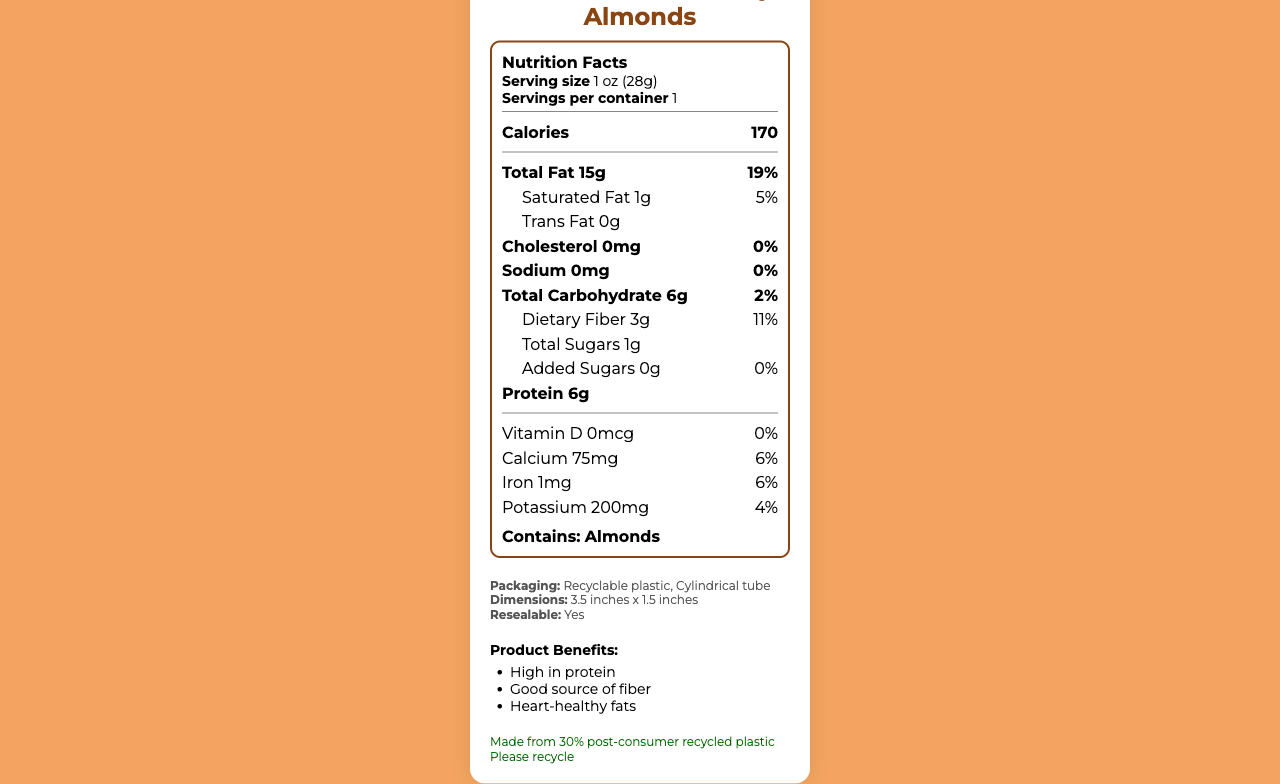what is the serving size? The serving size is stated right after the label "Serving size" within the "serving-info" section.
Answer: 1 oz (28g) how much protein does one serving contain? The document lists "Protein 6g" under the nutrition facts section.
Answer: 6g how many calories are in one serving? The document lists "Calories 170" in bold under the Nutrition Facts heading.
Answer: 170 is there any cholesterol in SmartSnack Crunchy Almonds? The document specifies "Cholesterol 0mg" with a daily value of "0%", indicating no cholesterol.
Answer: No what allergens does the product contain? The allergen information is clearly stated at the bottom of the nutrition facts, noting "Contains: Almonds".
Answer: Almonds which nutrient has a daily value of 19%? The document lists "Total Fat 15g" next to "19%" indicating it's 19% of the daily value.
Answer: Total Fat what is the shape of the packaging? A. Box B. Cylindrical tube C. Bag The packaging features section specifies the shape as "Cylindrical tube".
Answer: B what material is used for the packaging? A. Cardboard B. Glass C. Recyclable plastic The packaging features section states that the material used is "Recyclable plastic".
Answer: C does the packaging have resealable features? The packaging features section indicates that the package is "Resealable: Yes".
Answer: Yes how is the product environmentally friendly? The sustainability section mentions that the packaging is made from 30% post-consumer recycled plastic and encourages recycling.
Answer: The packaging is made from 30% post-consumer recycled plastic which vitamin mentioned has a daily value of 0%? The document lists "Vitamin D 0mcg" with a daily value of "0%", showing it does not contribute to daily Vitamin D intake.
Answer: Vitamin D name one benefit of the product. The product benefits section lists multiple benefits, including "High in protein" as one of them.
Answer: High in protein what is the tagline for the portion control messaging? The portion control messaging section includes the tagline "Perfect portion, powerful nutrition".
Answer: Perfect portion, powerful nutrition does the product contain any added sugars? The document states "Added Sugars 0g" with a daily value of "0%".
Answer: No summerize the entire document. This is a comprehensive description of the entire document and the information it provides.
Answer: The Nutrition Facts Label for SmartSnack Crunchy Almonds provides detailed nutritional information for a single-serve package. It emphasizes portion control with clear serving sizes and nutritional values, including 170 calories, 15g of total fat (19% DV), and 6g of protein. The allergen section advises that the product contains almonds. The packaging is described as cylindrical, resealable, and made from recyclable plastic, supporting sustainability. Branding elements focus on cohesive visual design with primary and secondary colors, a specific font, and central logo placement. The product is promoted for its health benefits, on-the-go convenience, and eco-friendly packaging. It also includes a QR code linking to more nutrition information. how many servings are in one container? The document specifies "Servings per container: 1" in the serving information section.
Answer: 1 how many grams of dietary fiber does one serving have? The document indicates "Dietary Fiber 3g" under the nutrient section.
Answer: 3g can the fats in this snack be considered heart-healthy? Based on the product benefits section, the document states "Heart-healthy fats" as one of the benefits.
Answer: Yes what font is used in the branding elements? The branding elements section specifies the font as "Montserrat".
Answer: Montserrat does the label say this snack is ideal for any specific type of situation? The portion control messaging section states, "Ideal for on-the-go snacking".
Answer: Yes, ideal for on-the-go snacking is there any vitamin D in SmartSnack Crunchy Almonds? The document lists "Vitamin D 0mcg" indicating there is no Vitamin D.
Answer: No what percentage of calcium can one get from this serving? The calcium content in the nutrition facts states "6%".
Answer: 6% what is the color scheme mentioned in the document? This information is listed under the branding elements section.
Answer: Primary color: #8B4513, Secondary color: #F4A460 describe the package's dimensions. The packaging features section lists the dimensions as "3.5 inches x 1.5 inches".
Answer: 3.5 inches x 1.5 inches what benefits are highlighted for this product? The product benefits section lists these three benefits.
Answer: High in protein, Good source of fiber, Heart-healthy fats does the document state where to find more nutrition information? The barcode section mentions the QR code and its associated URL.
Answer: Yes, the barcode contains a QR code linking to https://smartsnack.com/nutrition what types of fats are contained in the product? The nutrient section lists "Total Fat 15g" and "Saturated Fat 1g".
Answer: Total Fat and Saturated Fat what about the product's sodium content? The document lists "Sodium 0mg" with a daily value of "0%".
Answer: 0mg how much potassium is in one serving, and what percentage of the daily value does it represent? The nutritional facts section provides "Potassium 200mg", listed with "4%" of the daily value.
Answer: 200mg, 4% is the allergen info sufficient to determine if the product is gluten-free? The allergen info only specifies "Contains: Almonds", which is not enough to determine if it is gluten-free.
Answer: No, not enough information what type of barcode is used on the product? The barcode section states that the barcode type is a "QR code".
Answer: QR code 